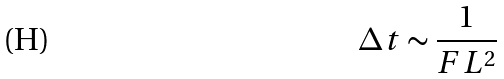<formula> <loc_0><loc_0><loc_500><loc_500>\Delta t \sim \frac { 1 } { F L ^ { 2 } }</formula> 